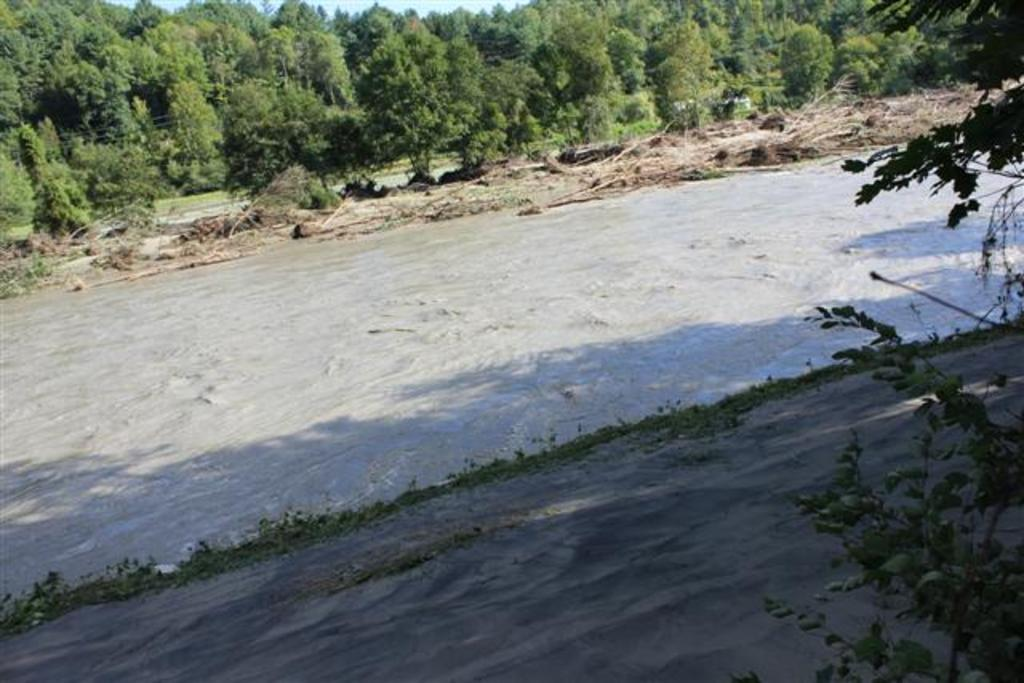What is present in the image? There is water in the image. What can be seen in the distance in the image? There are trees in the background of the image. What else is visible in the background of the image? The sky is visible in the background of the image. How much salt is dissolved in the water in the image? There is no information about salt in the image, so we cannot determine if any salt is dissolved in the water. 